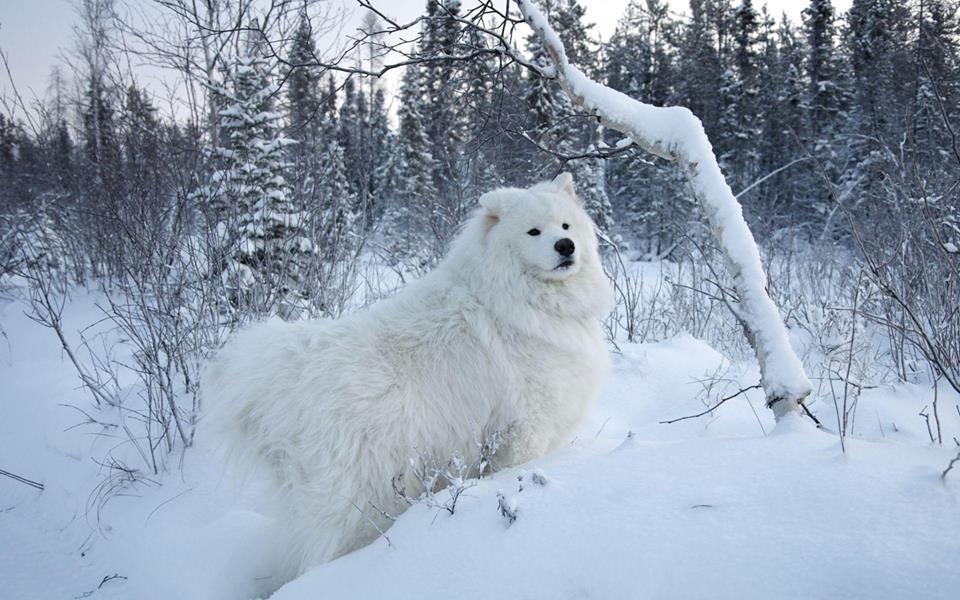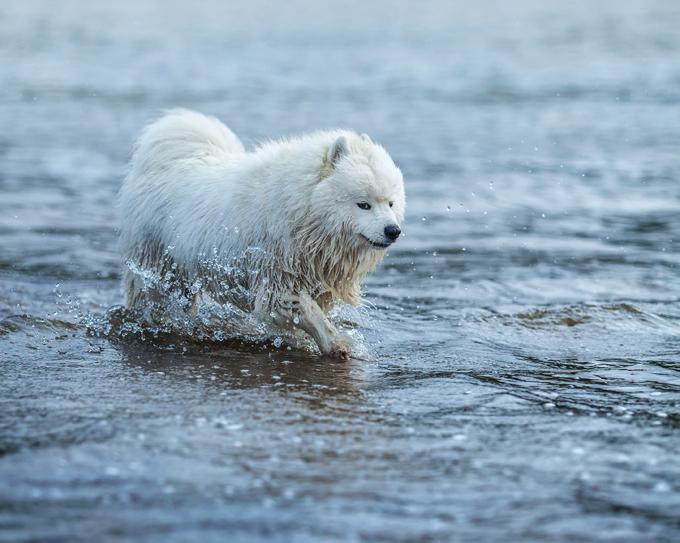The first image is the image on the left, the second image is the image on the right. For the images displayed, is the sentence "A white dog rounds up some sheep in one of the images." factually correct? Answer yes or no. No. The first image is the image on the left, the second image is the image on the right. Evaluate the accuracy of this statement regarding the images: "An image shows a white dog herding a group of sheep.". Is it true? Answer yes or no. No. 